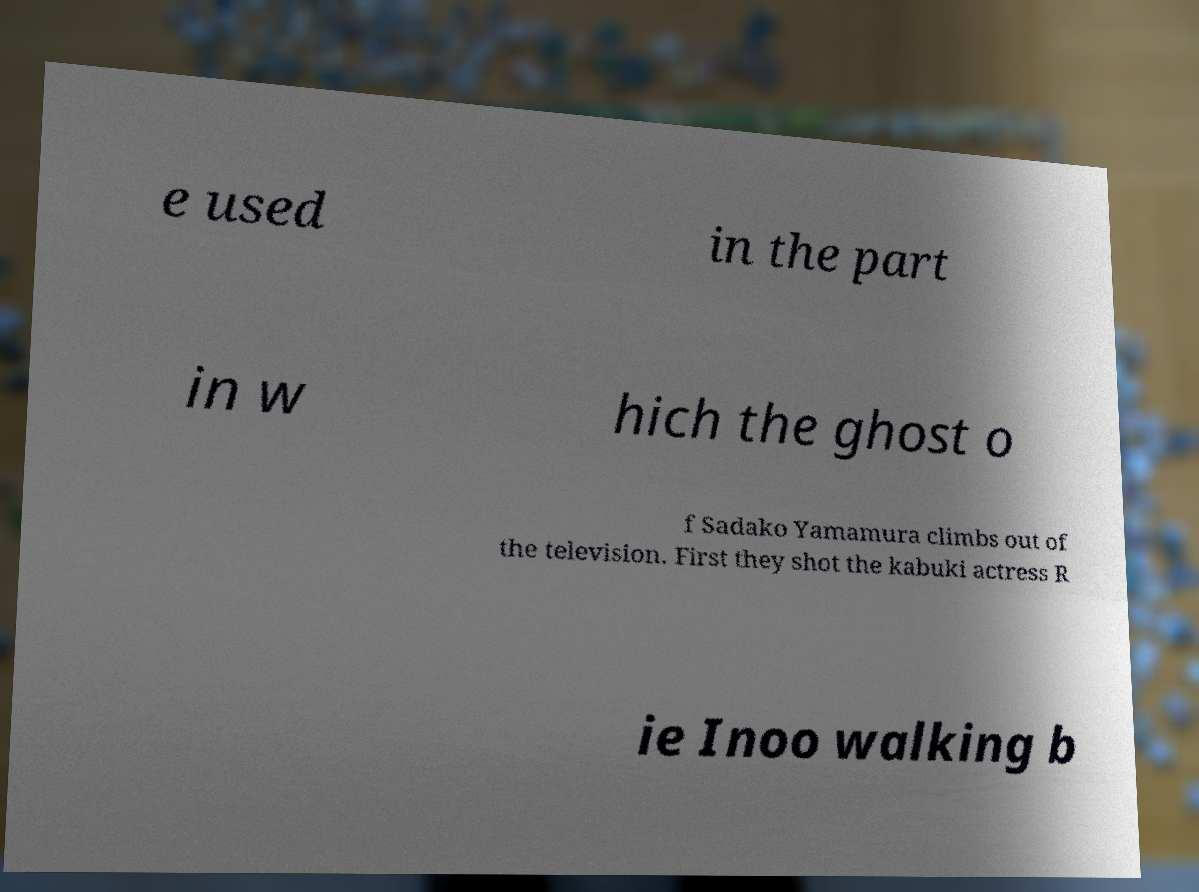For documentation purposes, I need the text within this image transcribed. Could you provide that? e used in the part in w hich the ghost o f Sadako Yamamura climbs out of the television. First they shot the kabuki actress R ie Inoo walking b 